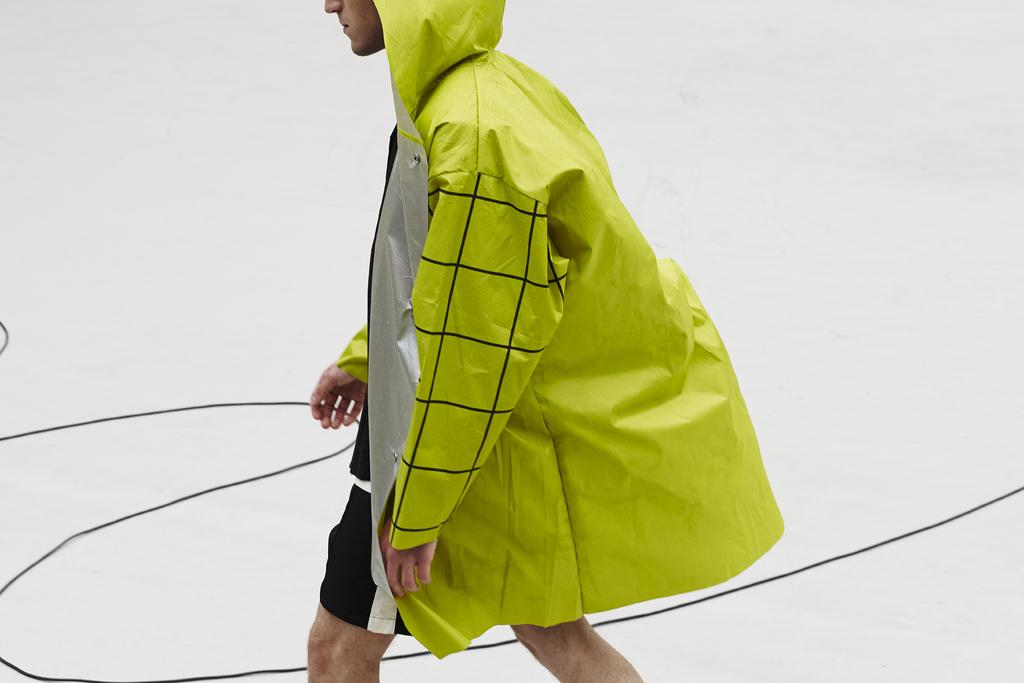What is the main subject of the image? There is a person in the image. What is the person doing in the image? The person is walking. What type of clothing is the person wearing in the image? The person is wearing a raincoat. Can you see a tiger walking alongside the person in the image? No, there is no tiger present in the image. Does the existence of the person in the image prove the existence of all other people? No, the existence of the person in the image does not prove the existence of all other people. 